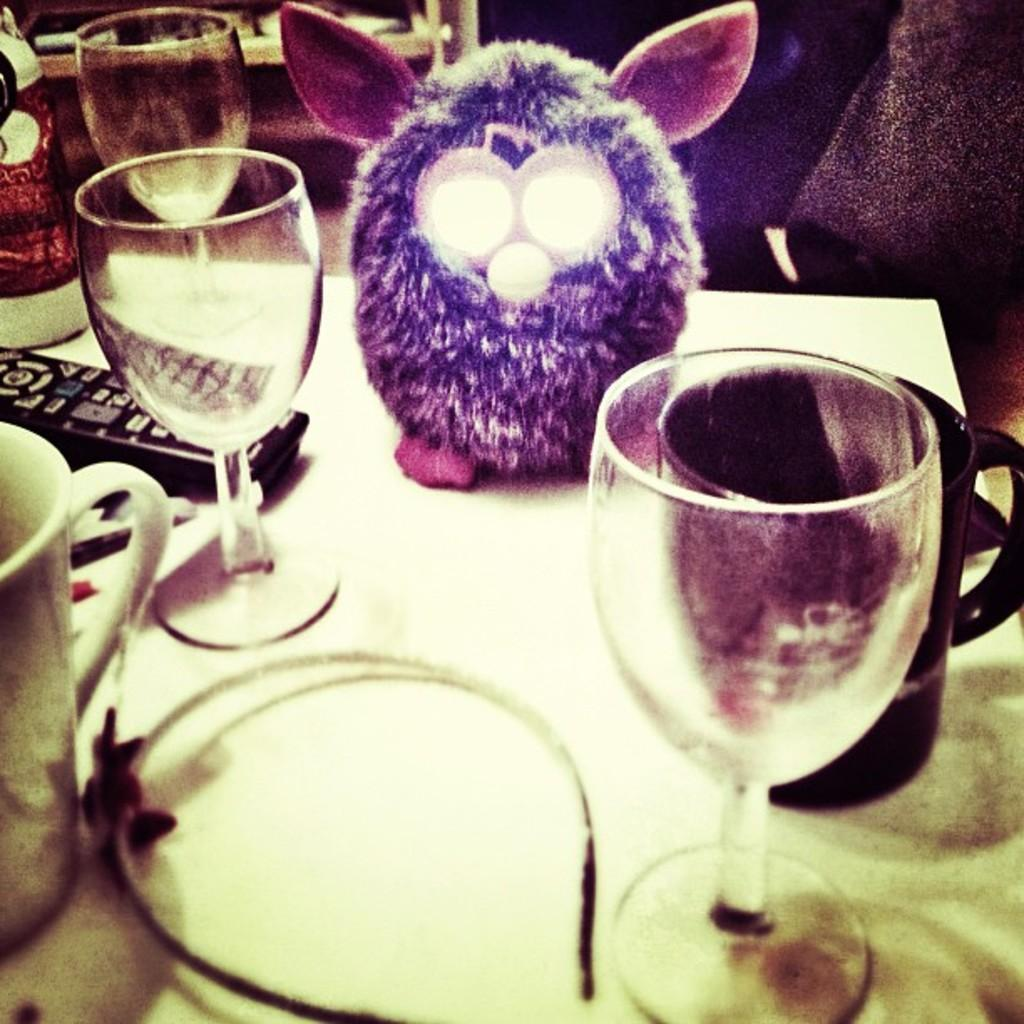What is the main object in the center of the image? There is a table in the center of the image. What items can be seen on the table? There are glasses, a remote, a toy, and a cup on the table. What might be used for controlling electronic devices in the image? The remote on the table can be used for controlling electronic devices. What might be used for holding a beverage in the image? The cup on the table can be used for holding a beverage. What type of coil is used to create the toy in the image? There is no coil present in the image, and the toy's construction is not described in the provided facts. 